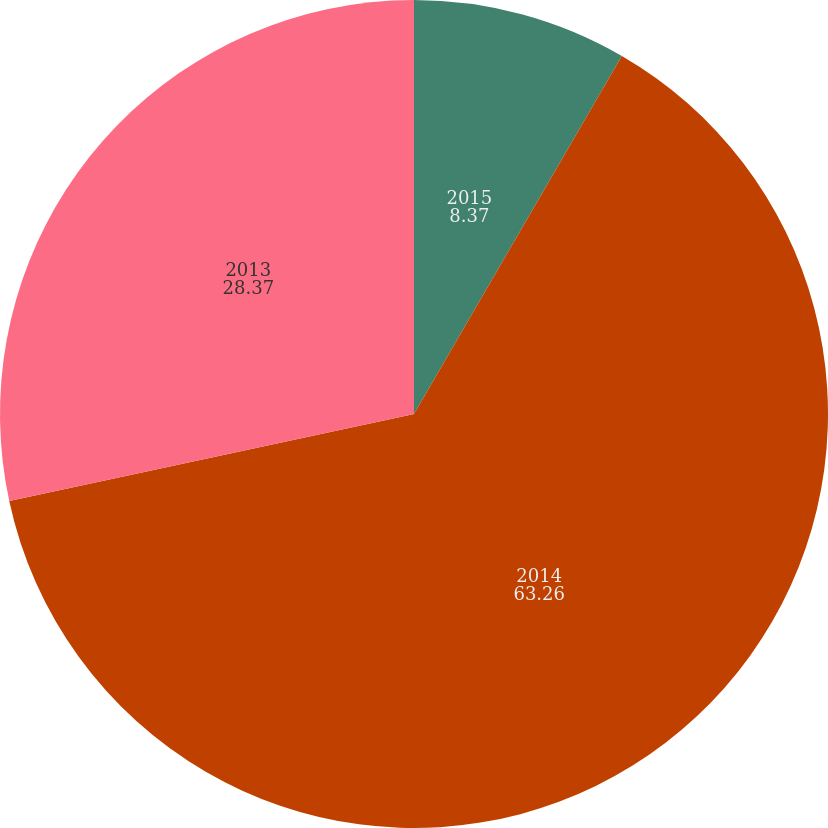<chart> <loc_0><loc_0><loc_500><loc_500><pie_chart><fcel>2015<fcel>2014<fcel>2013<nl><fcel>8.37%<fcel>63.26%<fcel>28.37%<nl></chart> 